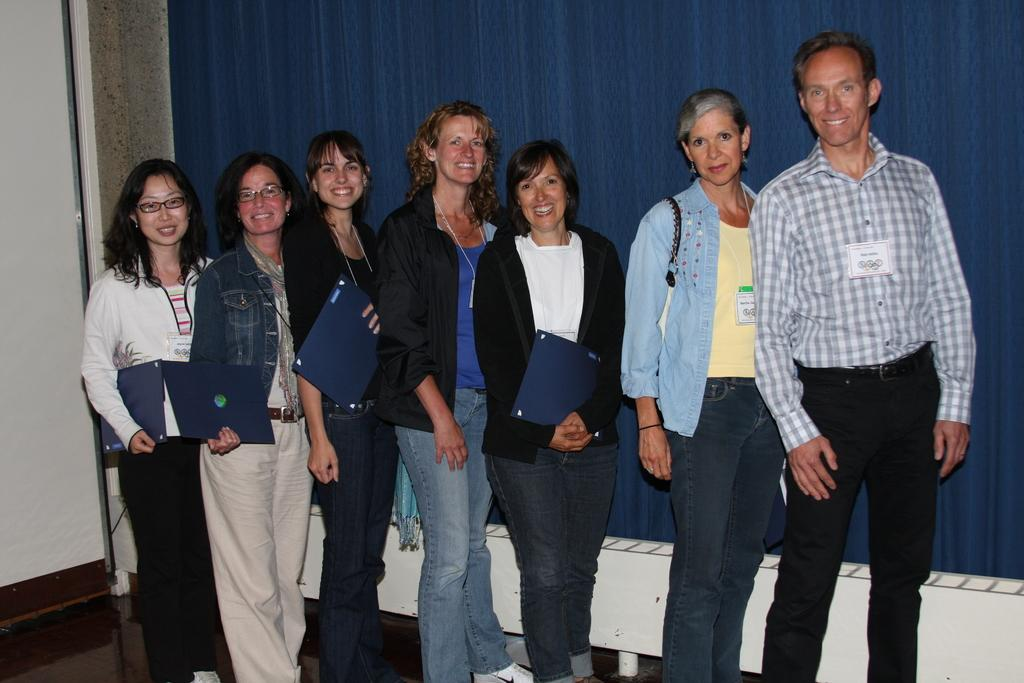What are the people in the image doing? The persons in the image are standing on the floor and smiling. What can be observed about their facial expressions? The persons are smiling in the image. What color is the background of the image? The background of the image is blue. What type of line can be seen blowing snow in the image? There is no line or snow present in the image; it features persons standing on the floor and smiling against a blue background. 